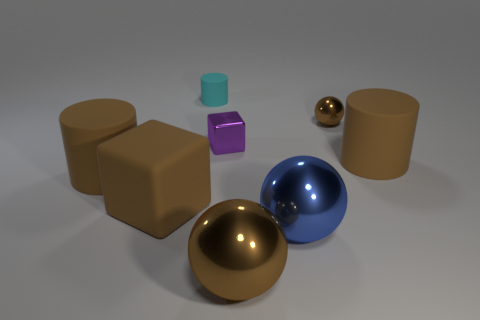What number of objects are either objects that are in front of the large cube or metal spheres in front of the big blue shiny sphere?
Your response must be concise. 2. What number of other objects are there of the same material as the blue ball?
Provide a short and direct response. 3. Does the tiny cylinder behind the tiny brown object have the same material as the big cube?
Offer a very short reply. Yes. Is the number of tiny matte objects that are behind the cyan cylinder greater than the number of large matte things in front of the tiny purple cube?
Provide a succinct answer. No. What number of things are brown shiny balls in front of the brown matte block or purple metal balls?
Your answer should be very brief. 1. There is a large brown thing that is the same material as the blue ball; what is its shape?
Offer a very short reply. Sphere. Is there any other thing that is the same shape as the small cyan thing?
Your answer should be very brief. Yes. There is a rubber cylinder that is both on the left side of the small brown metal ball and in front of the small purple metal object; what is its color?
Give a very brief answer. Brown. What number of cylinders are large matte objects or tiny rubber objects?
Offer a terse response. 3. How many brown rubber objects are the same size as the blue sphere?
Keep it short and to the point. 3. 